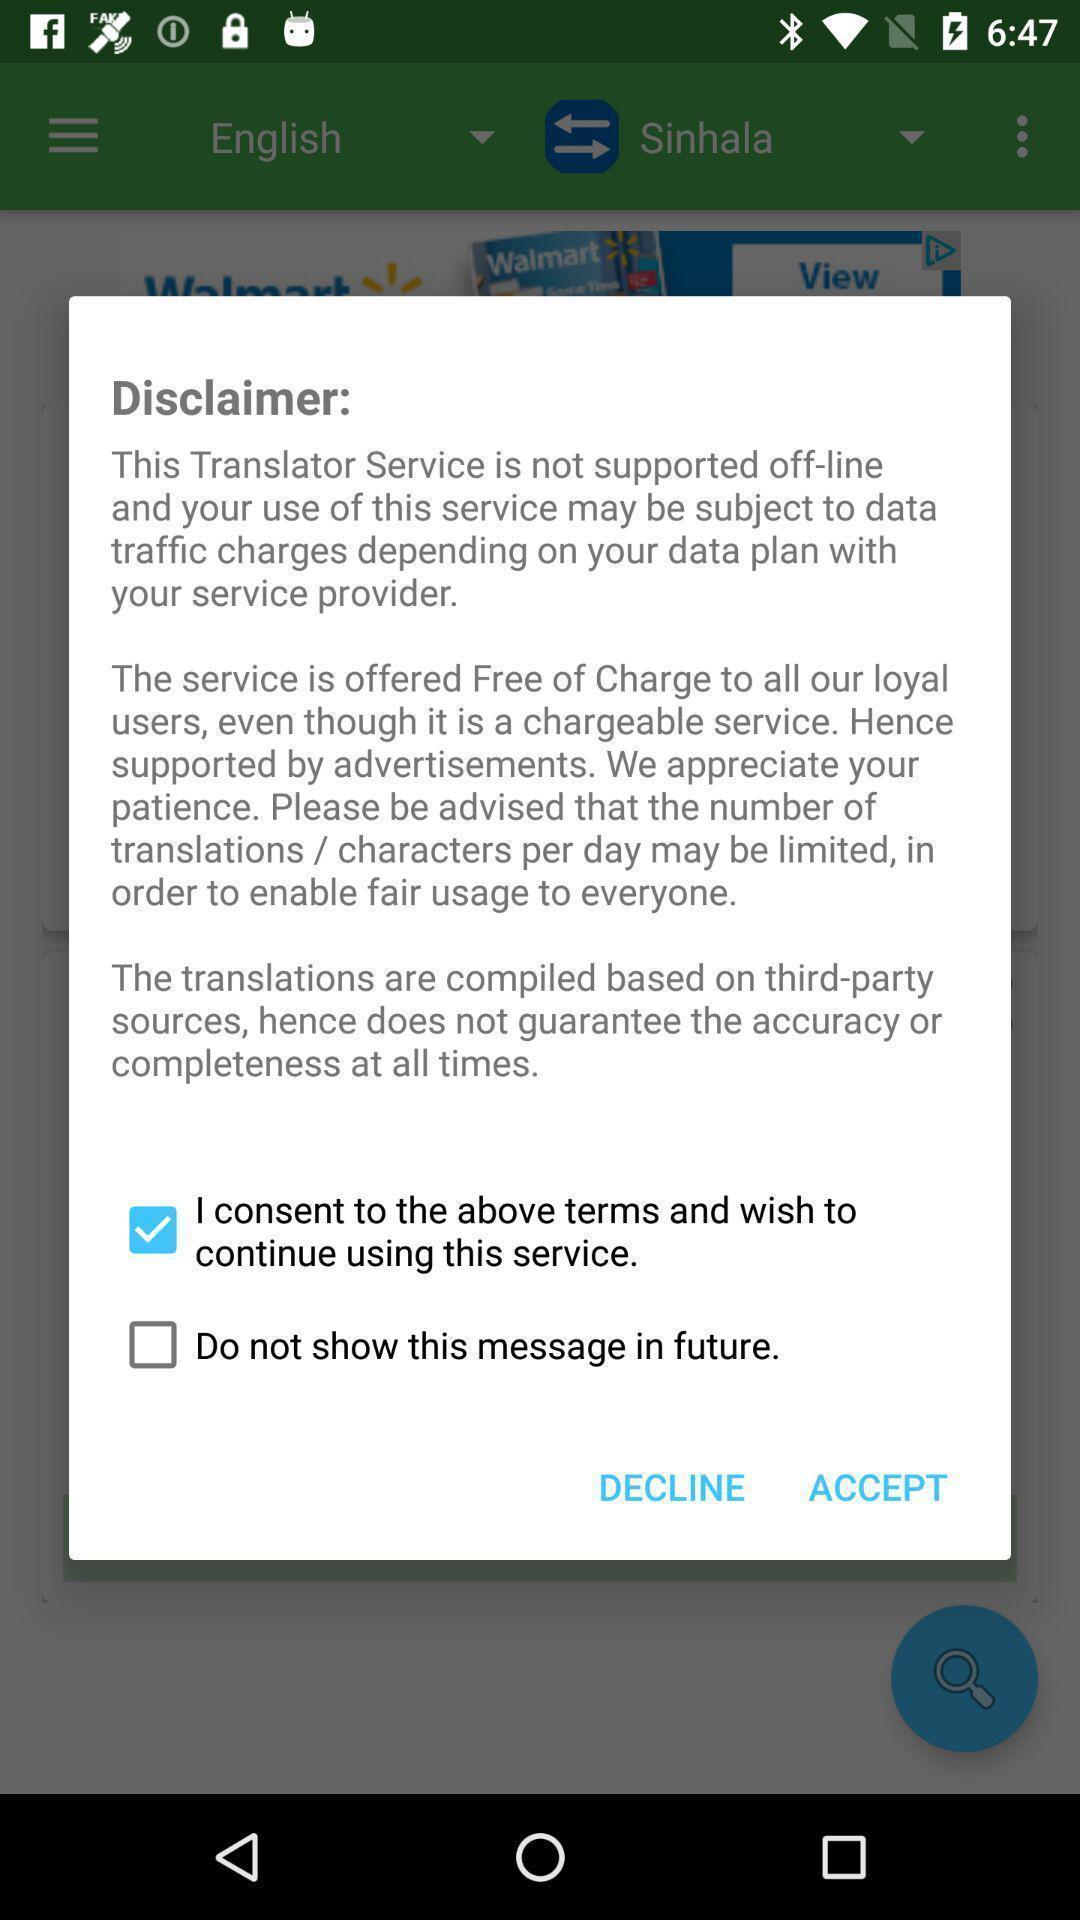Describe the visual elements of this screenshot. Popup displaying disclaimer information about an application. 